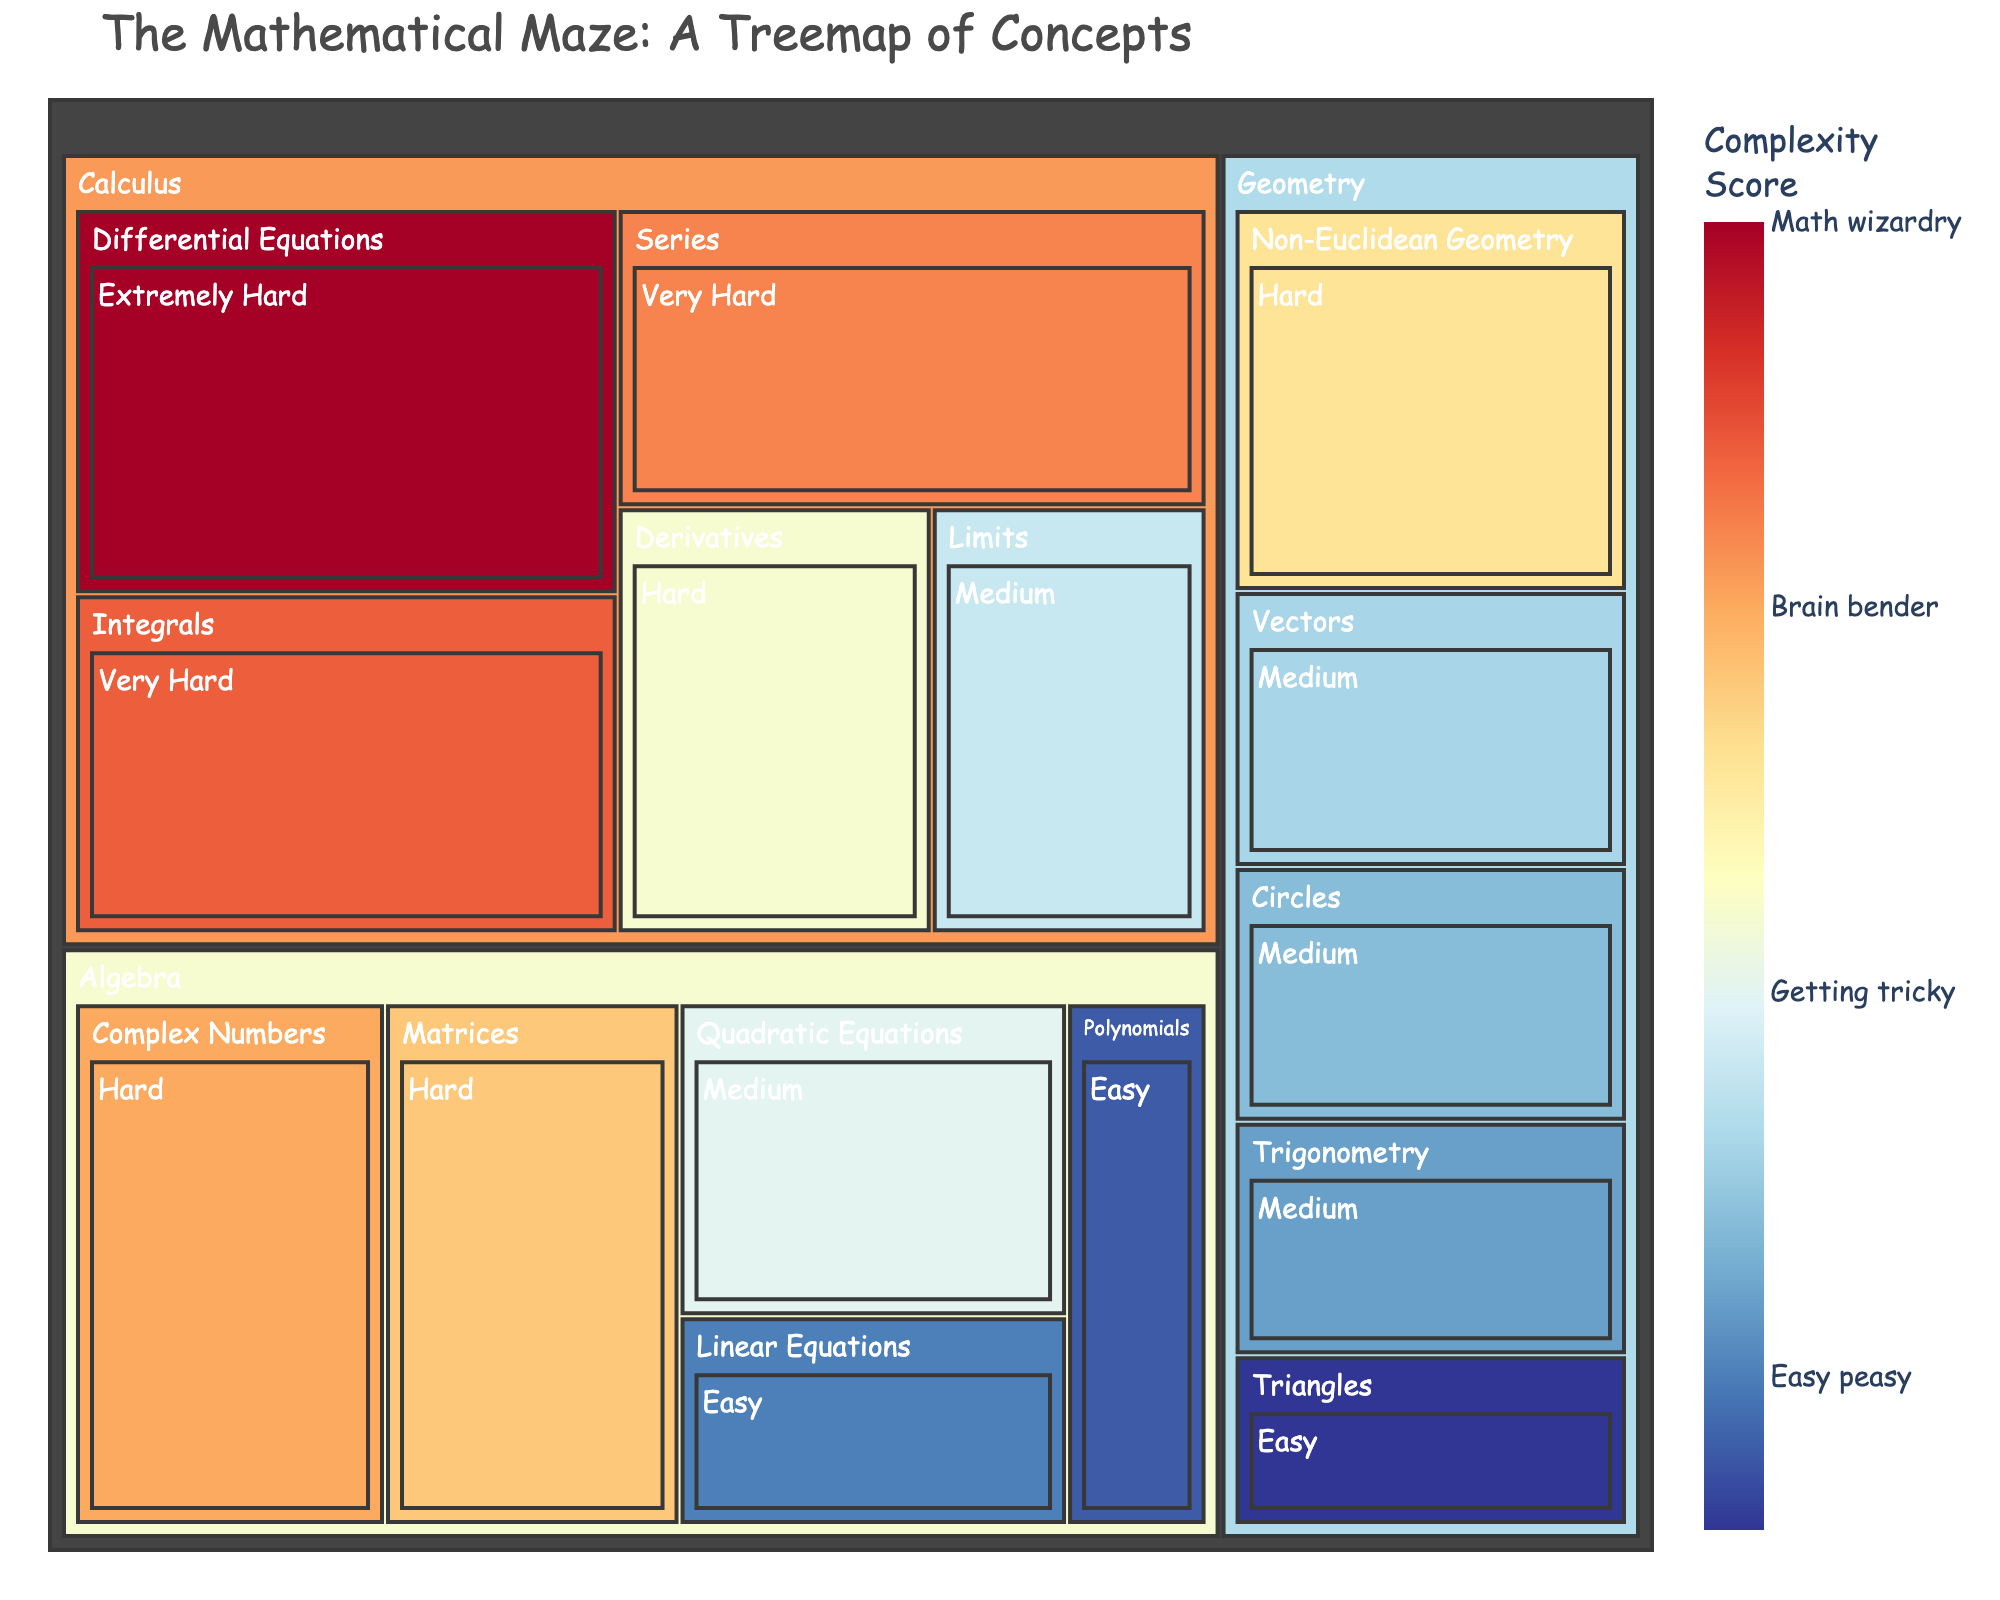What is the title of the treemap? The title is located at the top-center of the treemap and typically in a larger font size. It provides a concise summary of what the treemap represents.
Answer: The Mathematical Maze: A Treemap of Concepts What color scheme is used to represent the different complexity scores? The color scheme is shown in the color bar on the treemap. It ranges from blue (easy) to red (extremely hard), representing the complexity scores associated with each mathematical concept.
Answer: A blue-to-red (diverging) color scale Which category has the highest sum of complexity scores? To find this, we sum the values of each subcategory within a category. Algebra: 10+15+20+19+9 = 73, Geometry: 8+12+18+13+11 = 62, Calculus: 14+16+22+21+25 = 98.
Answer: Calculus What's the combined complexity score for all "Very Hard" subcategories? Identify all subcategories labeled "Very Hard" and sum their values: Integrals (22) and Series (21).
Answer: 43 Among the easy difficulty subcategories, which has the lowest value? Compare the values of the subcategories labeled "Easy": Linear Equations (10), Triangles (8), Polynomials (9).
Answer: Triangles Which subcategory has the highest complexity score within the Calculus category? Look for the subcategory within Calculus that has the highest numerical value: Limits (14), Derivatives (16), Integrals (22), Series (21), Differential Equations (25).
Answer: Differential Equations How many subcategories within Algebra are considered "Hard"? Count the subcategories within Algebra labeled as "Hard": Complex Numbers, Matrices.
Answer: 2 What is the average complexity score for the Geometry subcategories? Add the values of all Geometry subcategories and divide by the number of subcategories: (8 + 12 + 18 + 13 + 11) / 5.
Answer: 12.4 Which subcategory has the lowest complexity score overall? Compare the lowest values in all subcategories: Linear Equations (10), Triangles (8), etc.
Answer: Triangles Compare the "Medium" difficulty levels between Algebra and Geometry. Which has a higher total value? Calculate the sum for Medium in both categories: Algebra (Quadratic Equations 15), Geometry (Circles 12, Vectors 13, Trigonometry 11). Algebra = 15, Geometry = 12+13+11 = 36.
Answer: Geometry 